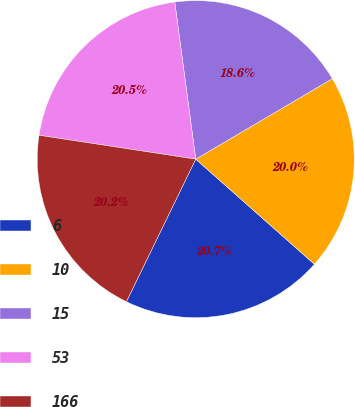Convert chart. <chart><loc_0><loc_0><loc_500><loc_500><pie_chart><fcel>6<fcel>10<fcel>15<fcel>53<fcel>166<nl><fcel>20.67%<fcel>20.01%<fcel>18.64%<fcel>20.48%<fcel>20.2%<nl></chart> 